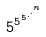Convert formula to latex. <formula><loc_0><loc_0><loc_500><loc_500>5 ^ { 5 ^ { 5 ^ { . ^ { . ^ { n } } } } }</formula> 